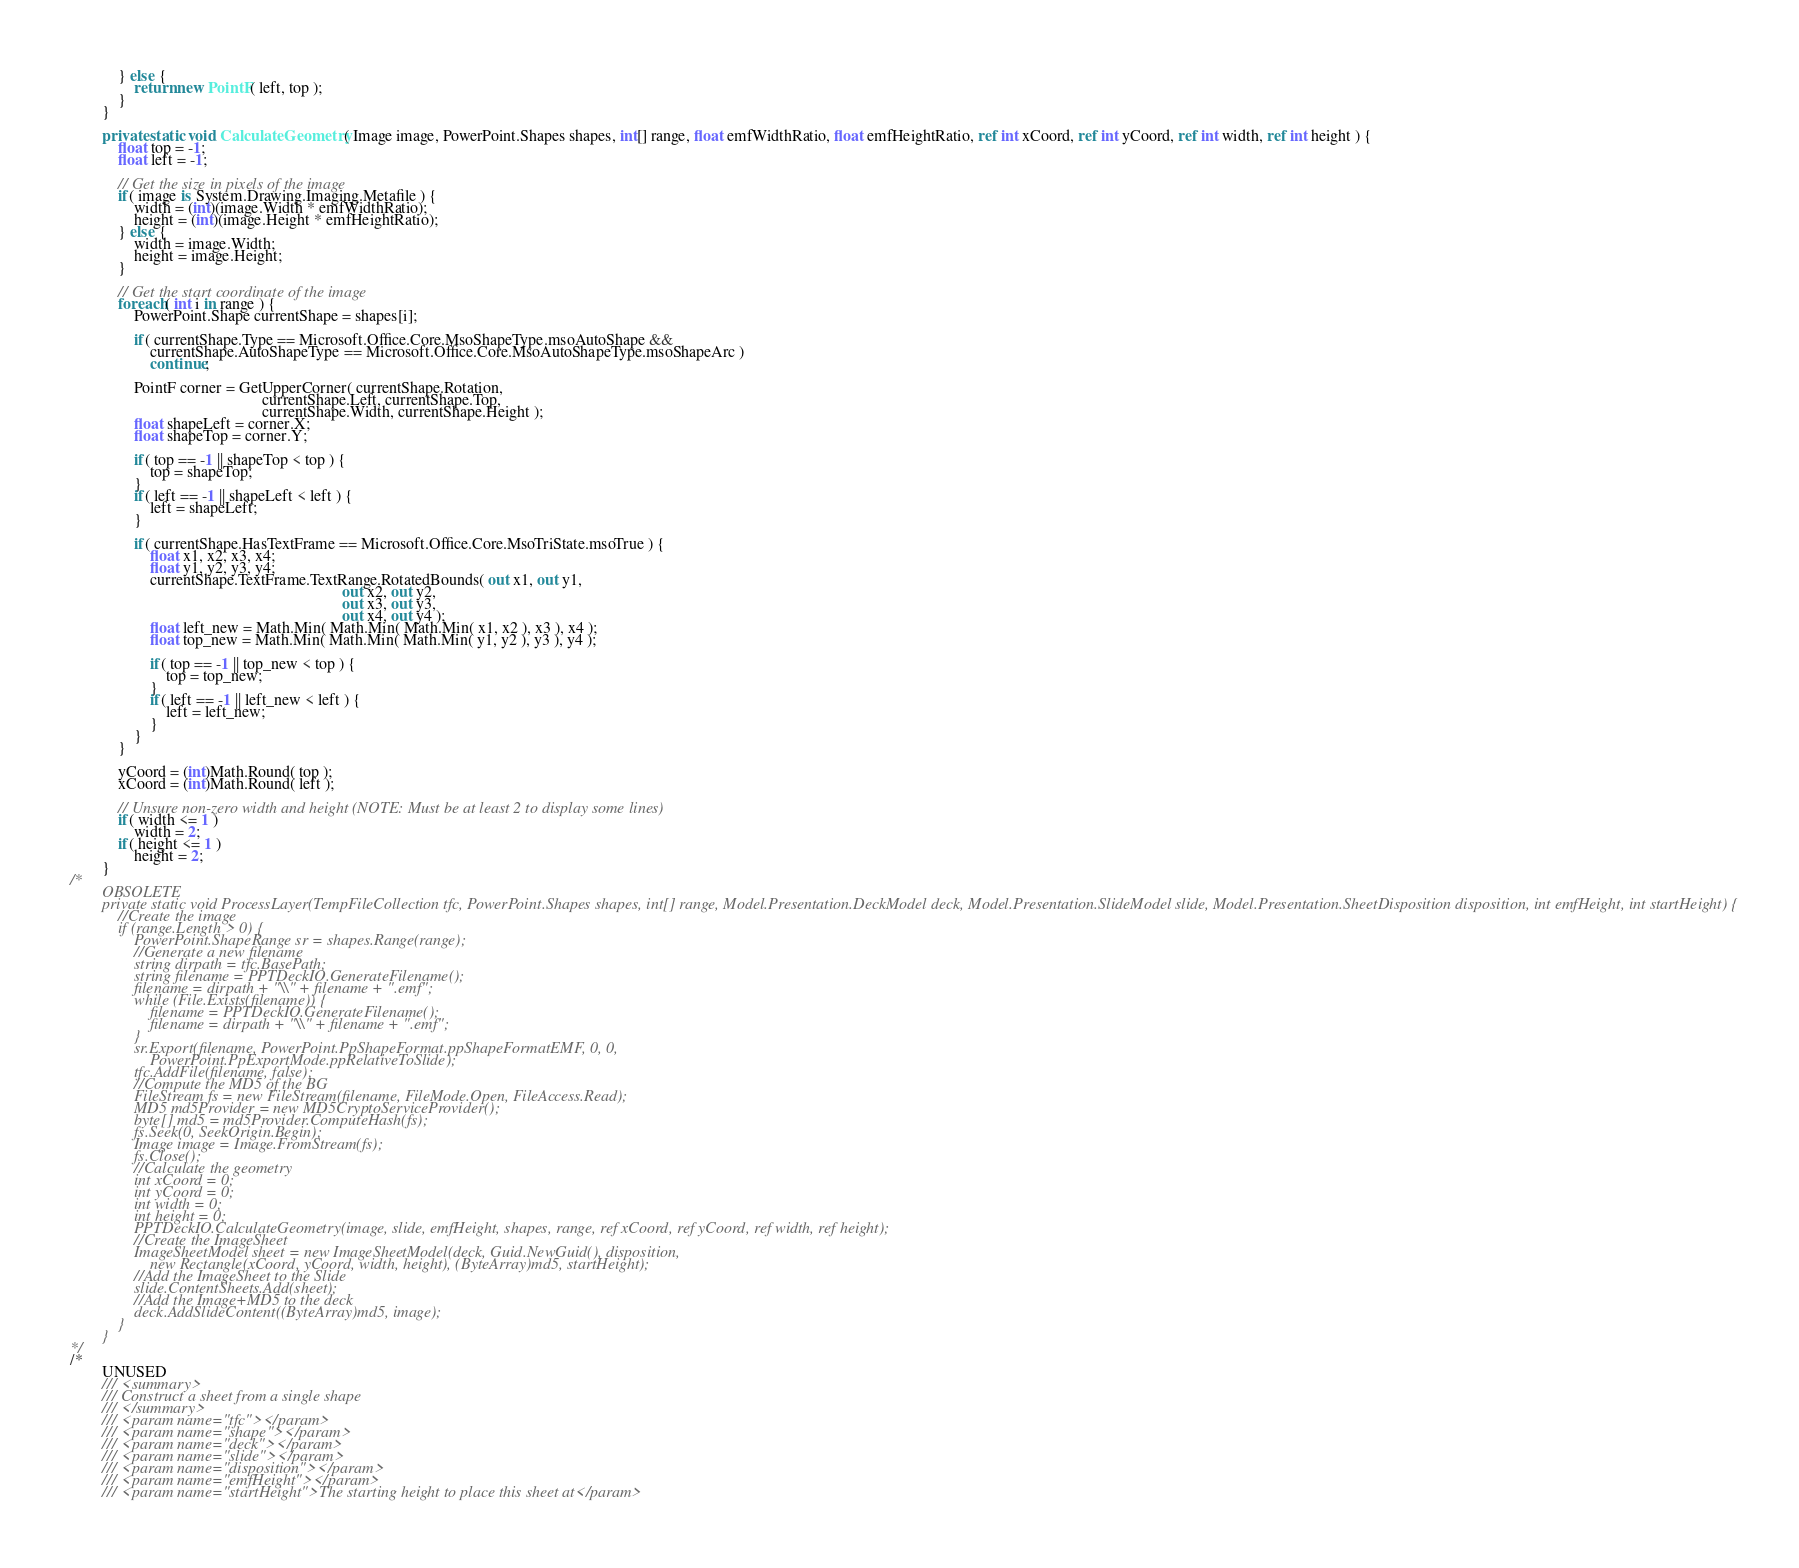<code> <loc_0><loc_0><loc_500><loc_500><_C#_>            } else {
                return new PointF( left, top );
            }
        }

        private static void CalculateGeometry( Image image, PowerPoint.Shapes shapes, int[] range, float emfWidthRatio, float emfHeightRatio, ref int xCoord, ref int yCoord, ref int width, ref int height ) {
            float top = -1;
            float left = -1;

            // Get the size in pixels of the image
            if( image is System.Drawing.Imaging.Metafile ) {
                width = (int)(image.Width * emfWidthRatio);
                height = (int)(image.Height * emfHeightRatio);
            } else {
                width = image.Width;
                height = image.Height;
            }

            // Get the start coordinate of the image
            foreach( int i in range ) {
                PowerPoint.Shape currentShape = shapes[i];

                if( currentShape.Type == Microsoft.Office.Core.MsoShapeType.msoAutoShape &&
                    currentShape.AutoShapeType == Microsoft.Office.Core.MsoAutoShapeType.msoShapeArc )
                    continue;

                PointF corner = GetUpperCorner( currentShape.Rotation, 
                                                currentShape.Left, currentShape.Top, 
                                                currentShape.Width, currentShape.Height );
                float shapeLeft = corner.X;
                float shapeTop = corner.Y;

                if( top == -1 || shapeTop < top ) {
                    top = shapeTop;
                }
                if( left == -1 || shapeLeft < left ) {
                    left = shapeLeft;
                }

                if( currentShape.HasTextFrame == Microsoft.Office.Core.MsoTriState.msoTrue ) {
                    float x1, x2, x3, x4;
                    float y1, y2, y3, y4;
                    currentShape.TextFrame.TextRange.RotatedBounds( out x1, out y1, 
                                                                    out x2, out y2, 
                                                                    out x3, out y3, 
                                                                    out x4, out y4 );
                    float left_new = Math.Min( Math.Min( Math.Min( x1, x2 ), x3 ), x4 );
                    float top_new = Math.Min( Math.Min( Math.Min( y1, y2 ), y3 ), y4 );

                    if( top == -1 || top_new < top ) {
                        top = top_new;
                    }
                    if( left == -1 || left_new < left ) {
                        left = left_new;
                    }
                }
            }

            yCoord = (int)Math.Round( top );
            xCoord = (int)Math.Round( left );

            // Unsure non-zero width and height (NOTE: Must be at least 2 to display some lines)
            if( width <= 1 )
                width = 2;
            if( height <= 1 )
                height = 2;
        }
/*
        OBSOLETE
        private static void ProcessLayer(TempFileCollection tfc, PowerPoint.Shapes shapes, int[] range, Model.Presentation.DeckModel deck, Model.Presentation.SlideModel slide, Model.Presentation.SheetDisposition disposition, int emfHeight, int startHeight) {
            //Create the image
            if (range.Length > 0) {
                PowerPoint.ShapeRange sr = shapes.Range(range);
                //Generate a new filename
                string dirpath = tfc.BasePath;
                string filename = PPTDeckIO.GenerateFilename();
                filename = dirpath + "\\" + filename + ".emf";
                while (File.Exists(filename)) {
                    filename = PPTDeckIO.GenerateFilename();
                    filename = dirpath + "\\" + filename + ".emf";
                }
                sr.Export(filename, PowerPoint.PpShapeFormat.ppShapeFormatEMF, 0, 0,
                    PowerPoint.PpExportMode.ppRelativeToSlide);
                tfc.AddFile(filename, false);
                //Compute the MD5 of the BG
                FileStream fs = new FileStream(filename, FileMode.Open, FileAccess.Read);
                MD5 md5Provider = new MD5CryptoServiceProvider();
                byte[] md5 = md5Provider.ComputeHash(fs);
                fs.Seek(0, SeekOrigin.Begin);
                Image image = Image.FromStream(fs);
                fs.Close();
                //Calculate the geometry
                int xCoord = 0;
                int yCoord = 0;
                int width = 0;
                int height = 0;
                PPTDeckIO.CalculateGeometry(image, slide, emfHeight, shapes, range, ref xCoord, ref yCoord, ref width, ref height);
                //Create the ImageSheet
                ImageSheetModel sheet = new ImageSheetModel(deck, Guid.NewGuid(), disposition,
                    new Rectangle(xCoord, yCoord, width, height), (ByteArray)md5, startHeight);
                //Add the ImageSheet to the Slide
                slide.ContentSheets.Add(sheet);
                //Add the Image+MD5 to the deck
                deck.AddSlideContent((ByteArray)md5, image);
            }
        }
*/
/*
        UNUSED
        /// <summary>
        /// Construct a sheet from a single shape
        /// </summary>
        /// <param name="tfc"></param>
        /// <param name="shape"></param>
        /// <param name="deck"></param>
        /// <param name="slide"></param>
        /// <param name="disposition"></param>
        /// <param name="emfHeight"></param>
        /// <param name="startHeight">The starting height to place this sheet at</param></code> 